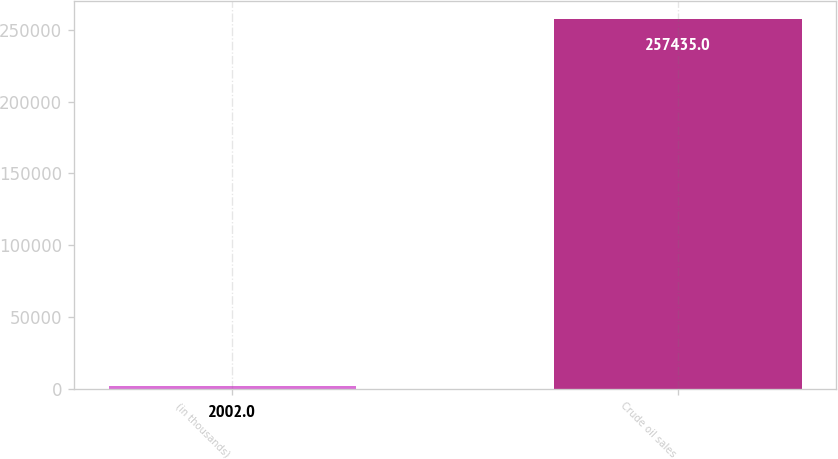Convert chart to OTSL. <chart><loc_0><loc_0><loc_500><loc_500><bar_chart><fcel>(in thousands)<fcel>Crude oil sales<nl><fcel>2002<fcel>257435<nl></chart> 